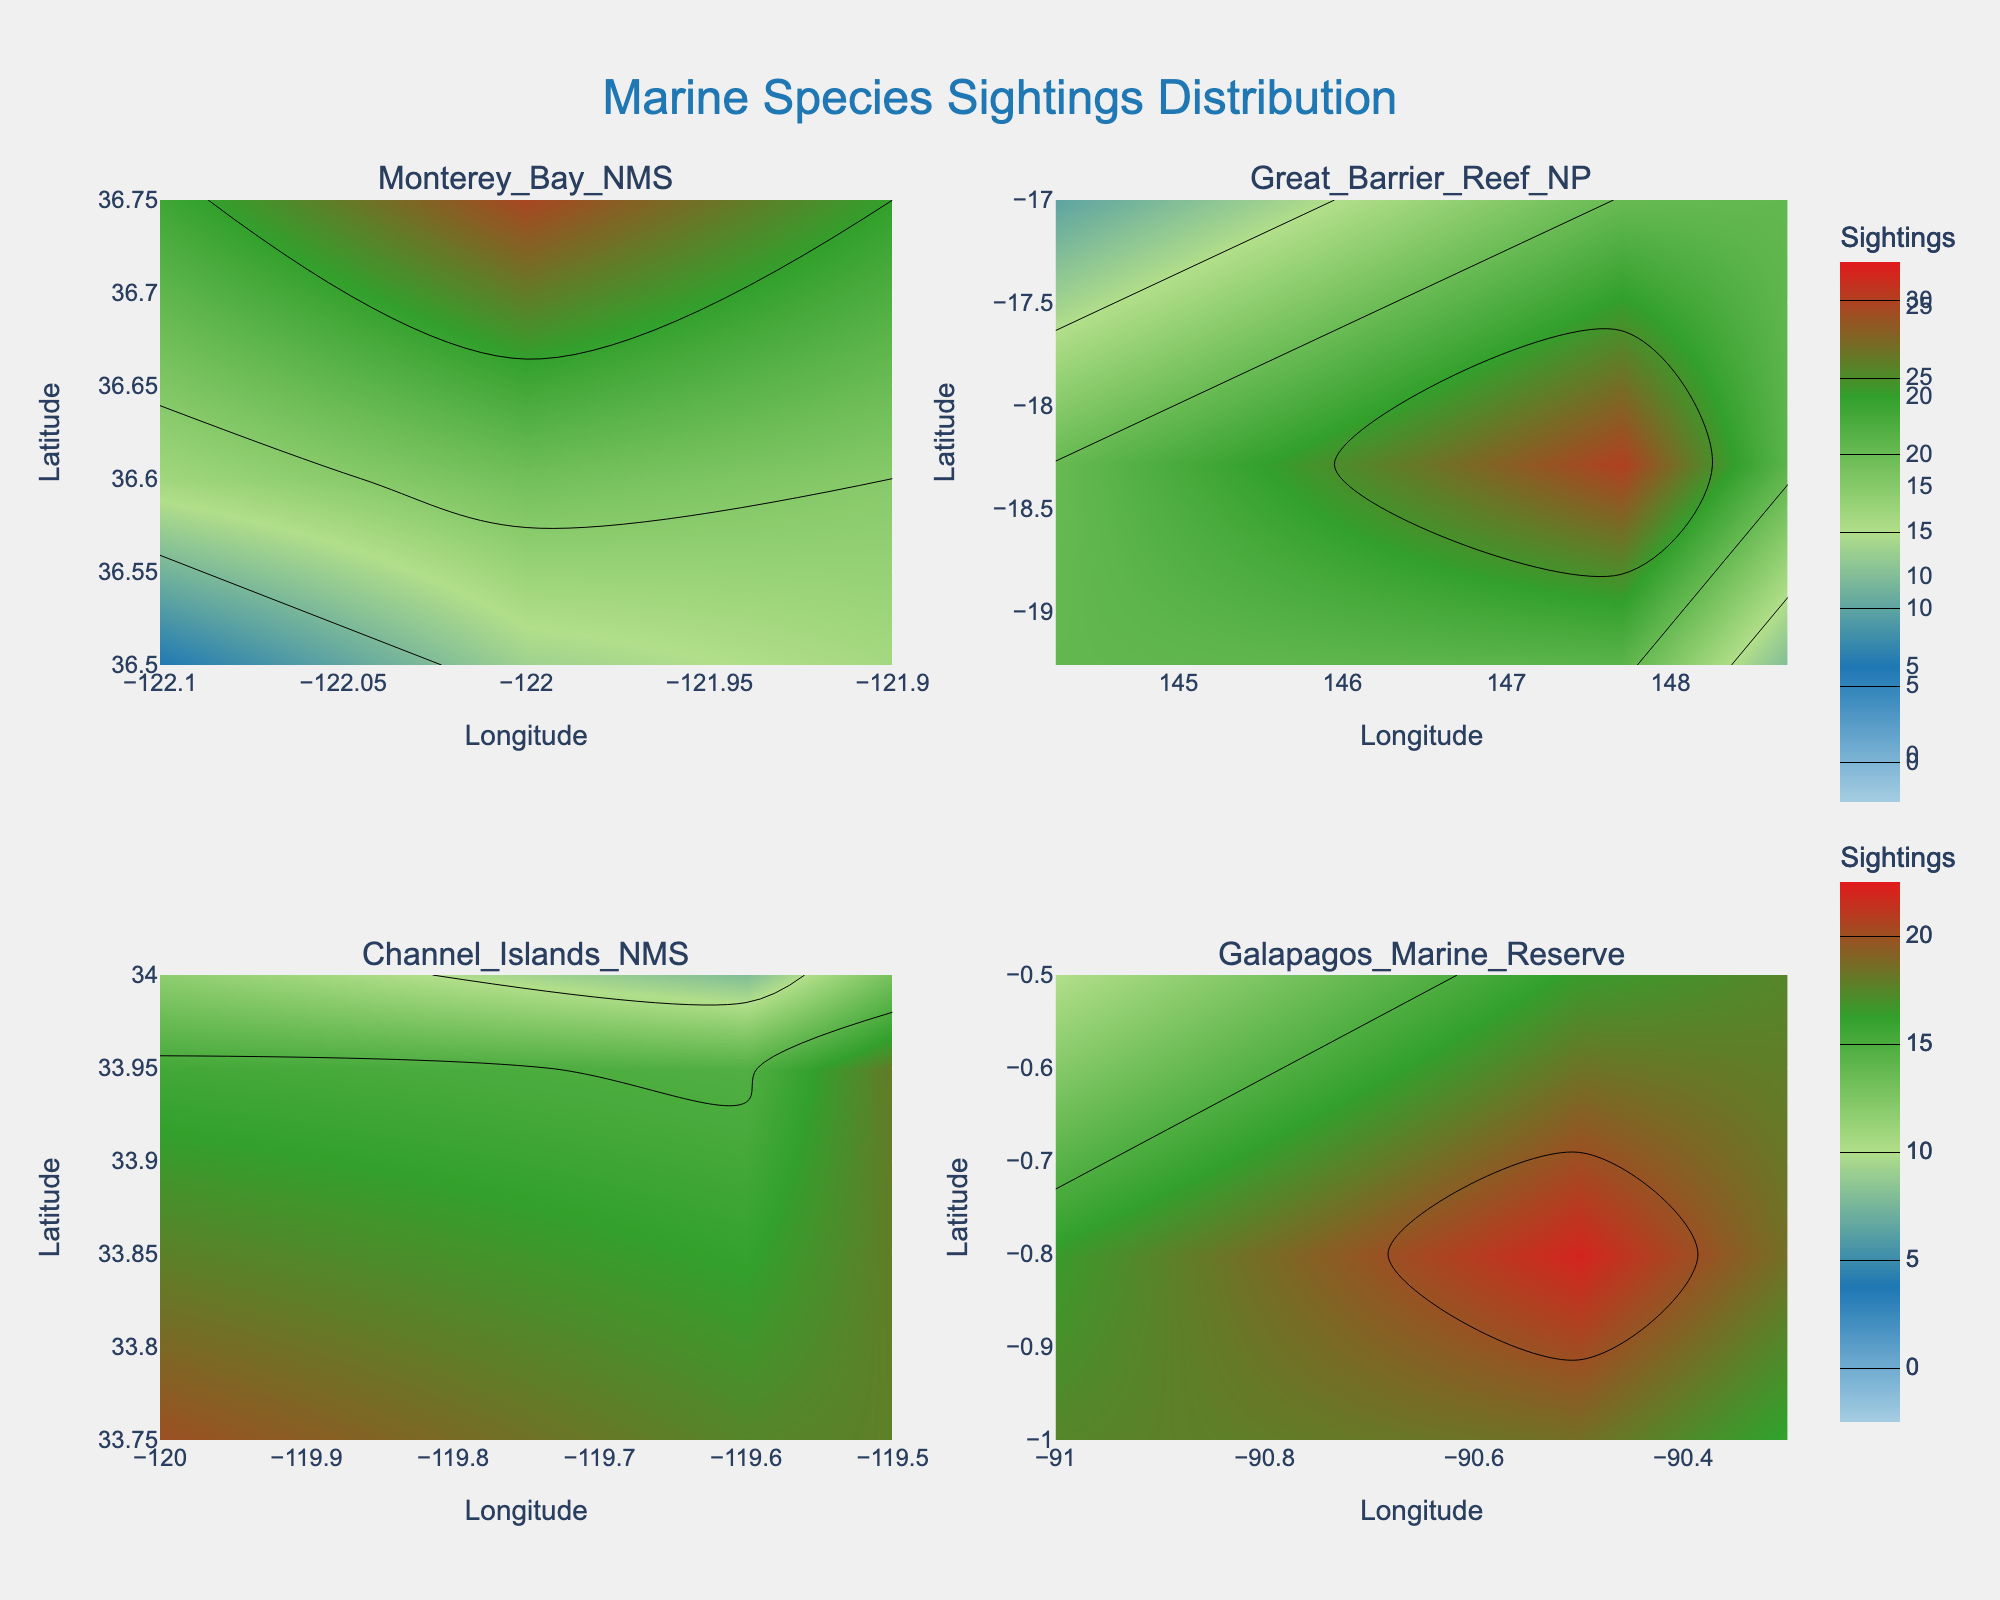How many species are sighted in the Monterey Bay National Marine Sanctuary? The Monterey Bay National Marine Sanctuary contains sightings of Dolphins, Sea Otters, and Gray Whales, which totals 3 species.
Answer: 3 Which Marine Protected Area has the highest sightings for a single species? In the Great Barrier Reef National Park, Clownfish have the highest sightings with 30. This is the maximum number of sightings for a single species across all areas.
Answer: Great Barrier Reef National Park What is the average number of sightings for species in the Galapagos Marine Reserve? The species in the Galapagos Marine Reserve have the following sightings: Galapagos Sharks (10), Marine Iguanas (22), Sea Lions (16). The average is calculated as (10 + 22 + 16) / 3 = 16.
Answer: 16 Which Marine Protected Area has the greatest range of Latitudes for sightings? The Great Barrier Reef National Park ranged from -19.2601 to -17.0000 in Latitude, a range of approximately 2.2601. This range is greater than those for the other areas.
Answer: Great Barrier Reef National Park Between Blue Whales in Channel Islands NMS and Gray Whales in Monterey Bay NMS, which has more sightings? Blue Whales in the Channel Islands NMS have 8 sightings, while Gray Whales in the Monterey Bay NMS have 5 sightings. Therefore, Blue Whales have more sightings.
Answer: Blue Whales What color indicates the highest number of sightings on the color scale? The highest color on the scale ranges from red to deep red, which corresponds to the highest sightings.
Answer: Red Which area has the highest number of different species mentioned? The Monterey Bay National Marine Sanctuary is mentioned for Dolphins, Sea Otters, and Gray Whales, totaling 3 species. Great Barrier Reef National Park also has 3 species but no more.
Answer: Tie (3 species each) What's the total number of sightings for all species in the Channel Islands NMS? Summing the sightings of Blue Whales (8), Kelp Forests (20), and Garibaldi (18) in the Channel Islands NMS: 8 + 20 + 18 = 46.
Answer: 46 At what Longitude and Latitude would you find the most sightings in the entire data set? Clownfish in the Great Barrier Reef National Park have 30 sightings, the highest in the entire dataset, found at Longitude 147.6992 and Latitude -18.2871.
Answer: 147.6992, -18.2871 